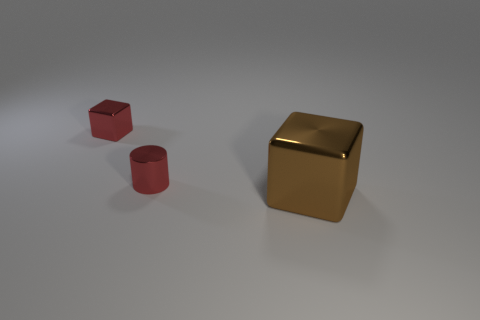Add 2 small red metal blocks. How many objects exist? 5 Subtract all blocks. How many objects are left? 1 Subtract all small shiny blocks. Subtract all big brown shiny things. How many objects are left? 1 Add 2 big brown blocks. How many big brown blocks are left? 3 Add 1 large matte cylinders. How many large matte cylinders exist? 1 Subtract 0 brown cylinders. How many objects are left? 3 